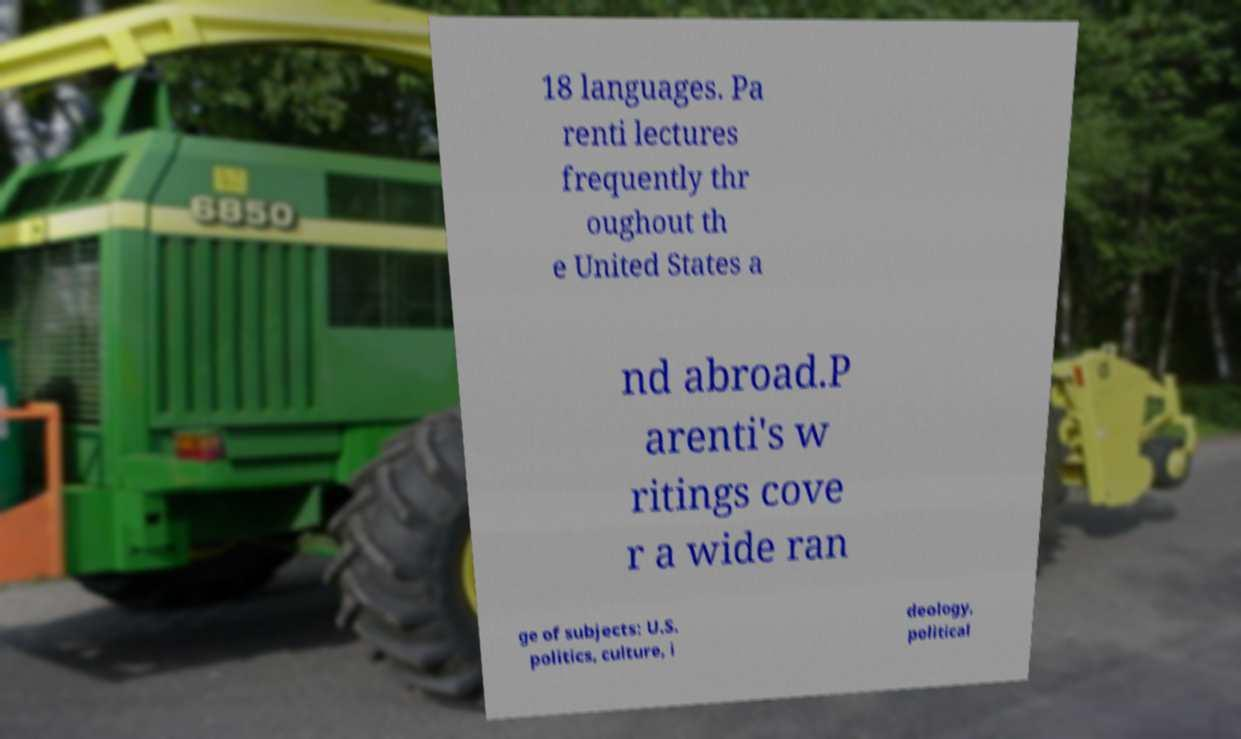Could you assist in decoding the text presented in this image and type it out clearly? 18 languages. Pa renti lectures frequently thr oughout th e United States a nd abroad.P arenti's w ritings cove r a wide ran ge of subjects: U.S. politics, culture, i deology, political 